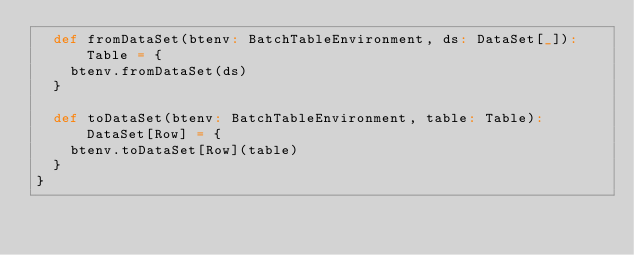<code> <loc_0><loc_0><loc_500><loc_500><_Scala_>  def fromDataSet(btenv: BatchTableEnvironment, ds: DataSet[_]): Table = {
    btenv.fromDataSet(ds)
  }

  def toDataSet(btenv: BatchTableEnvironment, table: Table): DataSet[Row] = {
    btenv.toDataSet[Row](table)
  }
}
</code> 